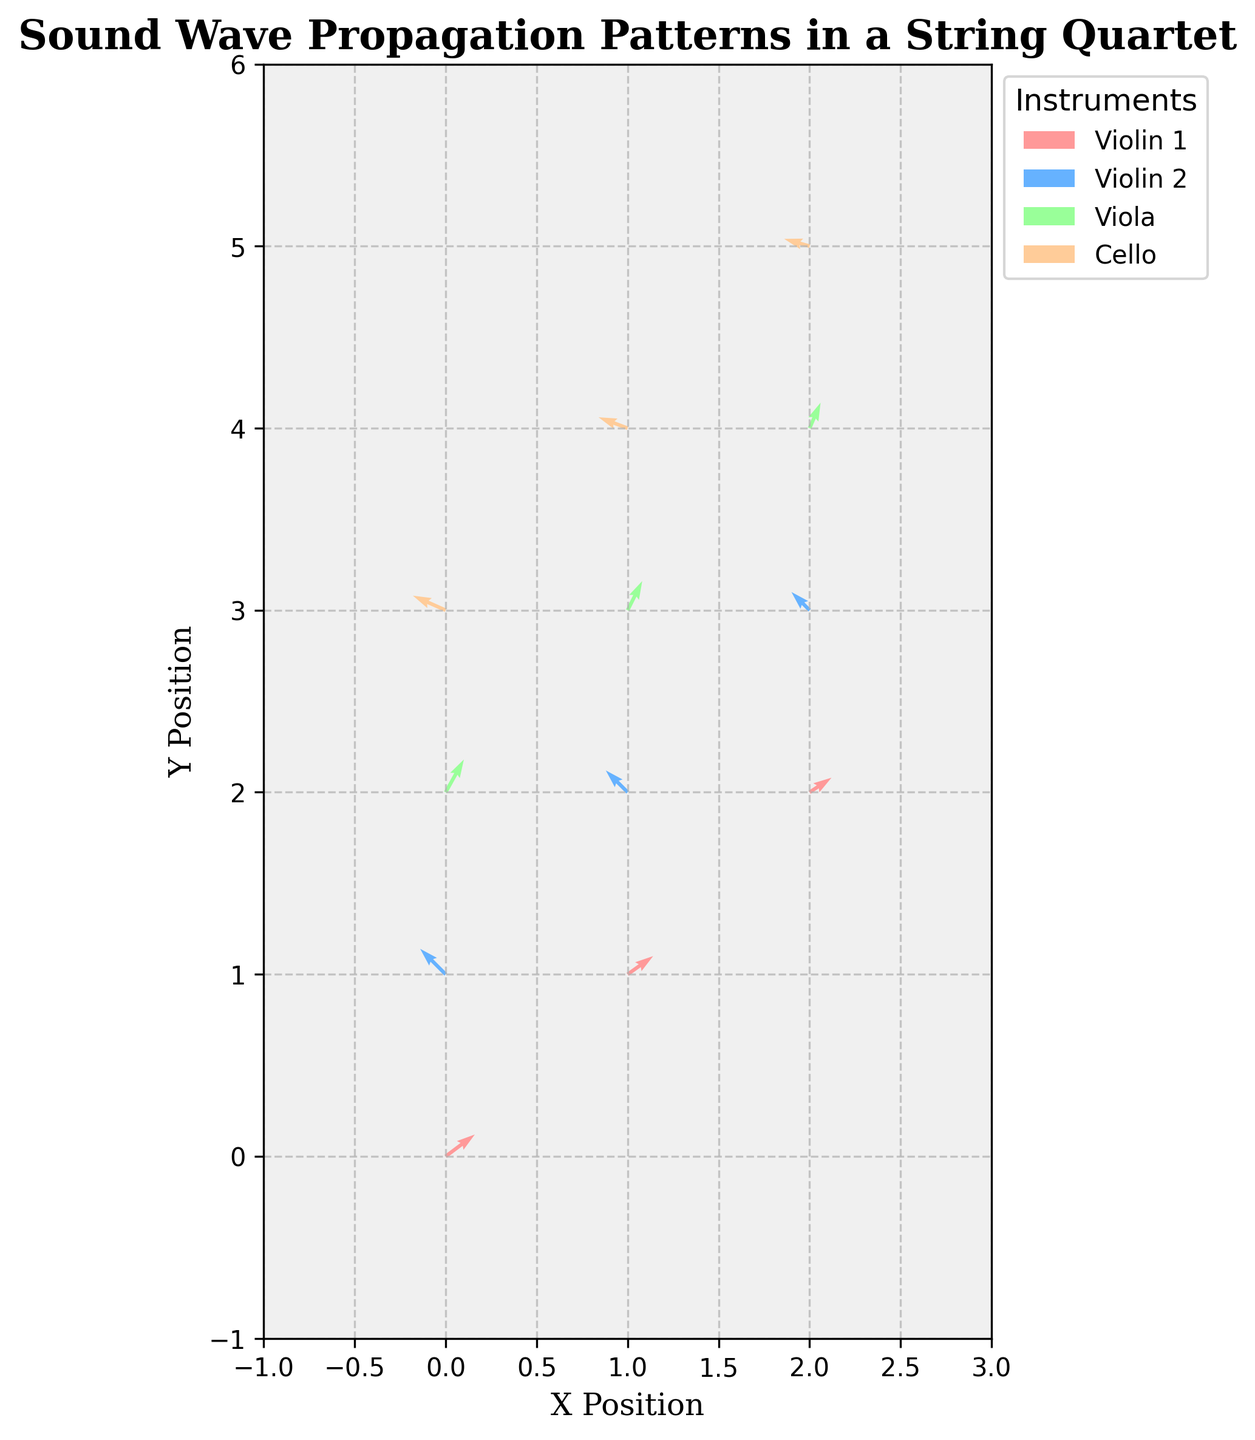What is the title of the plot? The title is positioned above the plot and labeled as "Sound Wave Propagation Patterns in a String Quartet".
Answer: Sound Wave Propagation Patterns in a String Quartet What are the x-axis and y-axis labels? The x-axis label is "X Position" and the y-axis label is "Y Position," both found along the respective axes of the plot.
Answer: X Position (x-axis), Y Position (y-axis) Which instrument produces the largest vector in the plot? By examining the lengths of the vectors, the Cello at position (0,3) produces the largest vector with components (-0.9, 0.4).
Answer: Cello What are the color codes used for the different instruments? The plot uses four different colors for the instruments: light red (Violin 1), light blue (Violin 2), light green (Viola), and light orange (Cello).
Answer: Light red, light blue, light green, light orange How many data points are represented for each instrument? Each instrument is represented by 3 data points, identifiable by the clustering of similar-colored vectors at different positions.
Answer: 3 data points Which instrument shows vectors with both positive u and v components? By inspecting the plot, Violin 1 and Viola show vectors where both u and v components are positive, indicating an upward and rightward direction.
Answer: Violin 1, Viola What is the common direction trend for Violin 2 vectors? The Violin 2 vectors, represented by light blue, all point to the upper left (negative u and positive v components).
Answer: Upper left For which instrument do the vectors point primarily downward? Examination of vector directions shows that Cello vectors tend to point downward (negative u component).
Answer: Cello Which instrument exhibits the least steep vectors in the plot? The Violin 1 vectors are less steep compared to others since their u-components are larger relative to their v-components.
Answer: Violin 1 What direction do most Viola vectors point towards? Observing the Viola vectors marked in light green, they generally point towards the North-East (positive u and positive v).
Answer: North-East 